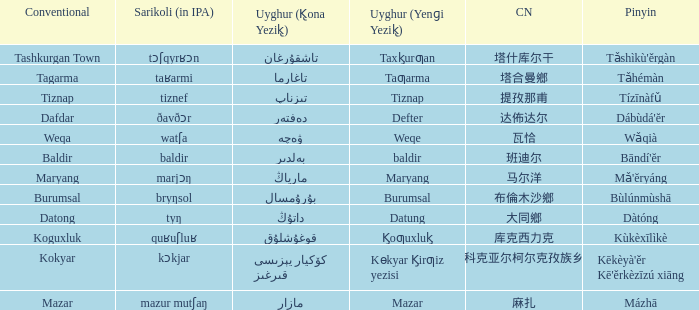Name the conventional for تاغارما Tagarma. 